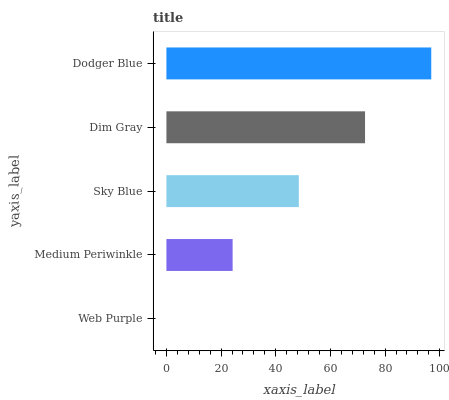Is Web Purple the minimum?
Answer yes or no. Yes. Is Dodger Blue the maximum?
Answer yes or no. Yes. Is Medium Periwinkle the minimum?
Answer yes or no. No. Is Medium Periwinkle the maximum?
Answer yes or no. No. Is Medium Periwinkle greater than Web Purple?
Answer yes or no. Yes. Is Web Purple less than Medium Periwinkle?
Answer yes or no. Yes. Is Web Purple greater than Medium Periwinkle?
Answer yes or no. No. Is Medium Periwinkle less than Web Purple?
Answer yes or no. No. Is Sky Blue the high median?
Answer yes or no. Yes. Is Sky Blue the low median?
Answer yes or no. Yes. Is Dodger Blue the high median?
Answer yes or no. No. Is Medium Periwinkle the low median?
Answer yes or no. No. 